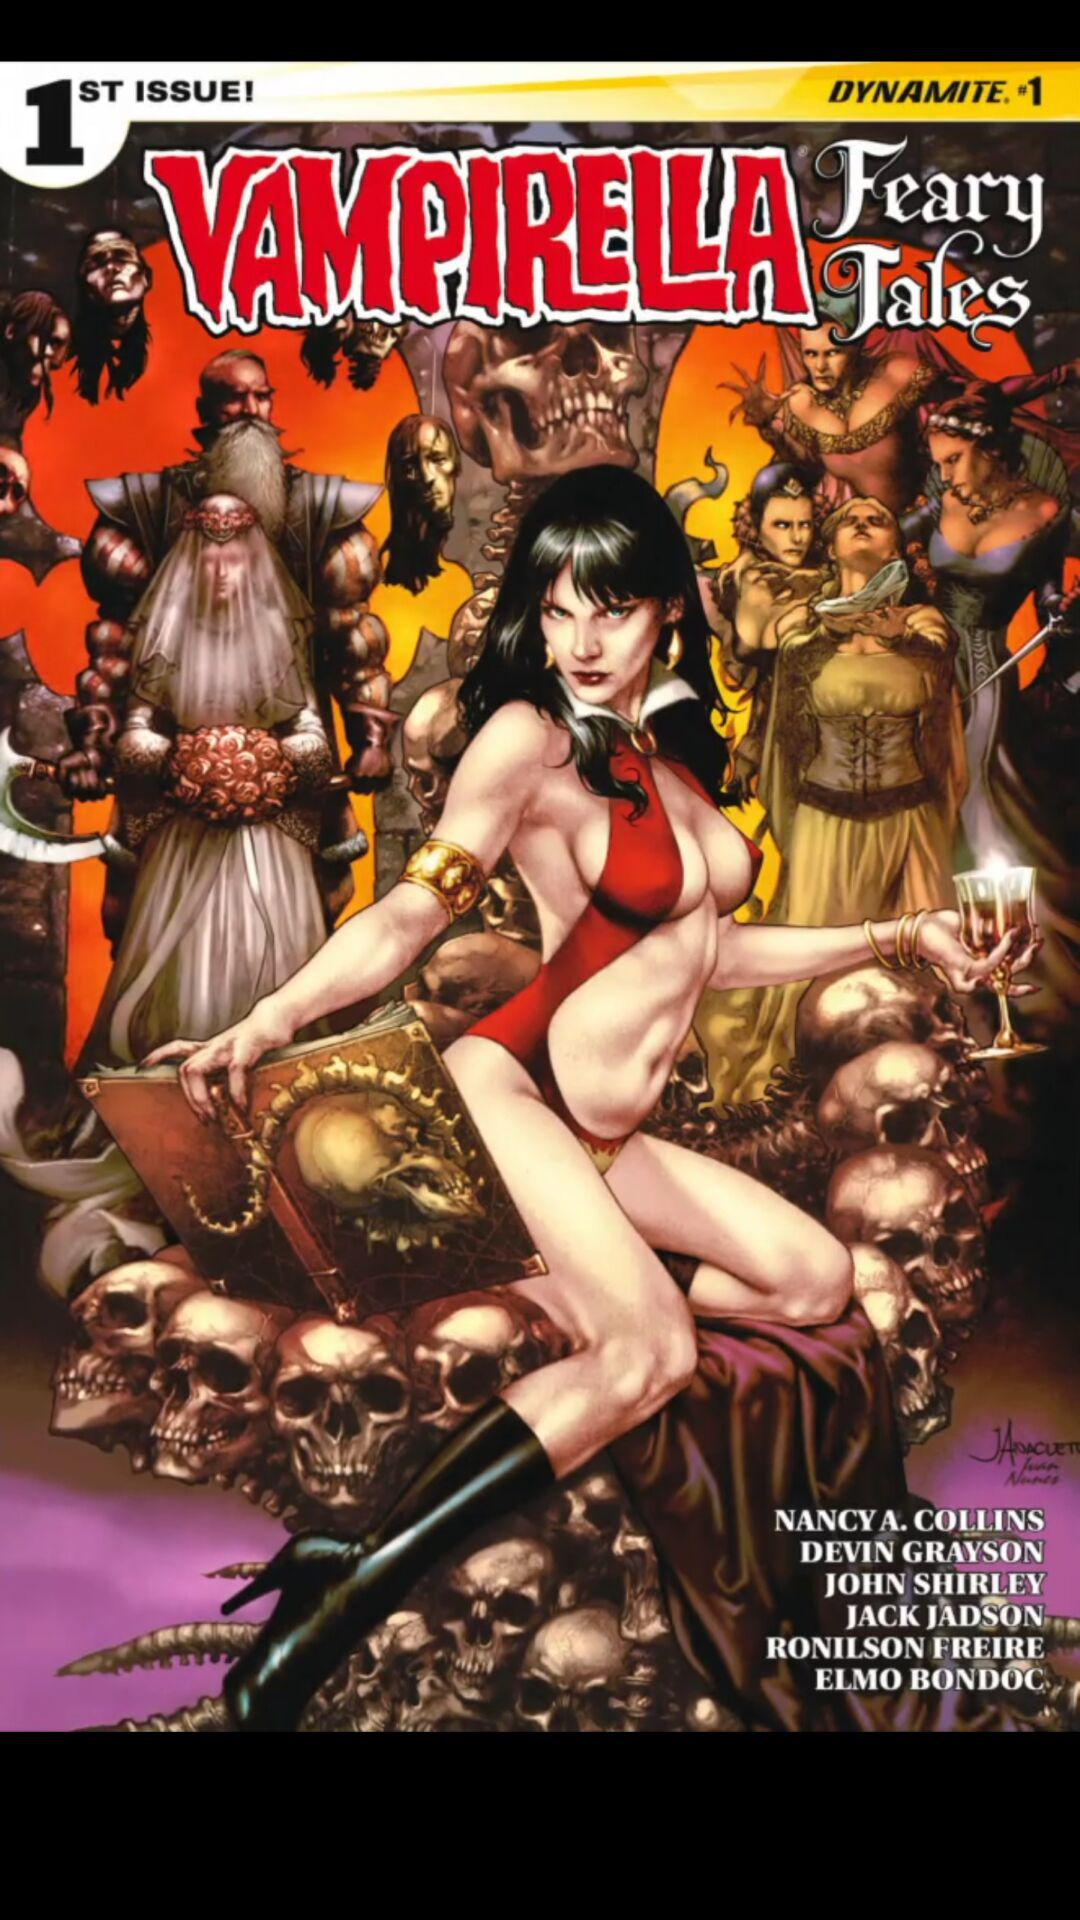What is the name of the book? The name of the book is "VAMPIRELLA Feary Tales". 